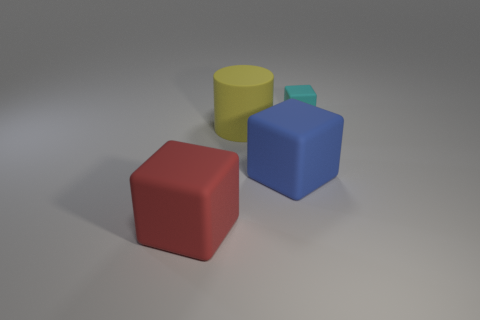Subtract all cyan matte blocks. How many blocks are left? 2 Add 2 big blue things. How many objects exist? 6 Subtract 0 cyan balls. How many objects are left? 4 Subtract all blocks. How many objects are left? 1 Subtract all green cylinders. Subtract all gray spheres. How many cylinders are left? 1 Subtract all red matte cubes. Subtract all blue matte objects. How many objects are left? 2 Add 4 tiny matte objects. How many tiny matte objects are left? 5 Add 2 cyan cubes. How many cyan cubes exist? 3 